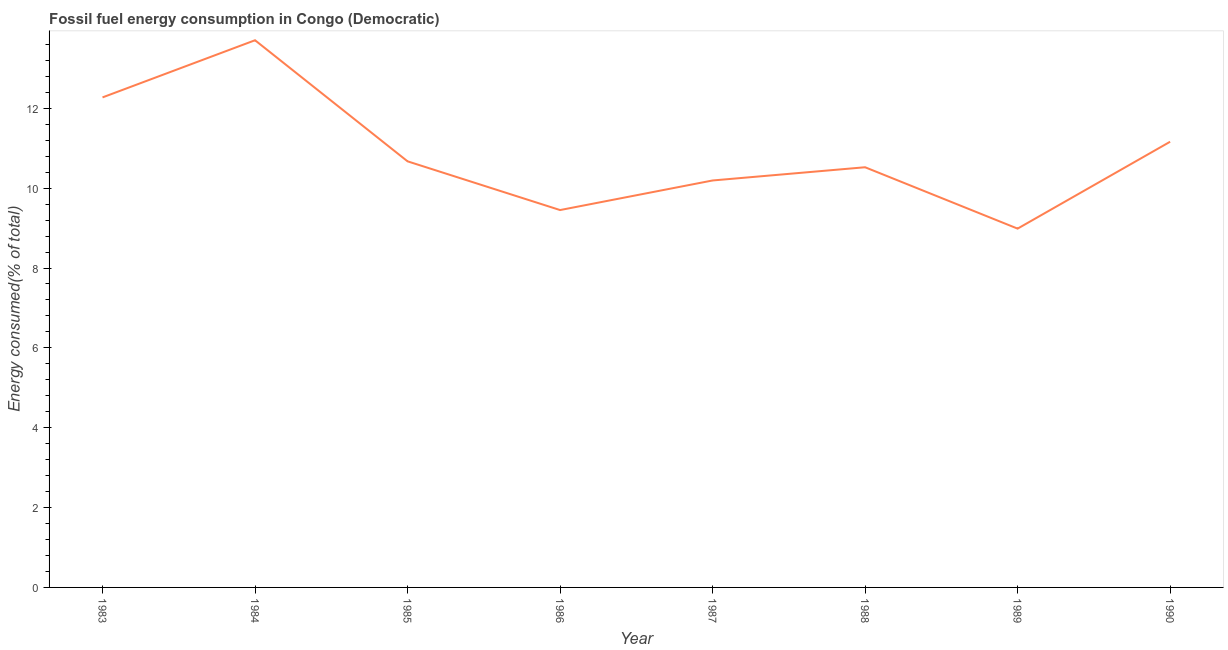What is the fossil fuel energy consumption in 1987?
Your answer should be compact. 10.19. Across all years, what is the maximum fossil fuel energy consumption?
Provide a succinct answer. 13.7. Across all years, what is the minimum fossil fuel energy consumption?
Your answer should be compact. 8.99. In which year was the fossil fuel energy consumption maximum?
Give a very brief answer. 1984. What is the sum of the fossil fuel energy consumption?
Make the answer very short. 86.97. What is the difference between the fossil fuel energy consumption in 1988 and 1989?
Your answer should be compact. 1.54. What is the average fossil fuel energy consumption per year?
Your answer should be very brief. 10.87. What is the median fossil fuel energy consumption?
Provide a short and direct response. 10.6. In how many years, is the fossil fuel energy consumption greater than 8 %?
Make the answer very short. 8. What is the ratio of the fossil fuel energy consumption in 1987 to that in 1990?
Your response must be concise. 0.91. What is the difference between the highest and the second highest fossil fuel energy consumption?
Your response must be concise. 1.43. Is the sum of the fossil fuel energy consumption in 1984 and 1988 greater than the maximum fossil fuel energy consumption across all years?
Your response must be concise. Yes. What is the difference between the highest and the lowest fossil fuel energy consumption?
Give a very brief answer. 4.72. How many years are there in the graph?
Provide a short and direct response. 8. Are the values on the major ticks of Y-axis written in scientific E-notation?
Make the answer very short. No. Does the graph contain any zero values?
Offer a very short reply. No. Does the graph contain grids?
Provide a succinct answer. No. What is the title of the graph?
Make the answer very short. Fossil fuel energy consumption in Congo (Democratic). What is the label or title of the Y-axis?
Ensure brevity in your answer.  Energy consumed(% of total). What is the Energy consumed(% of total) in 1983?
Offer a terse response. 12.27. What is the Energy consumed(% of total) of 1984?
Offer a very short reply. 13.7. What is the Energy consumed(% of total) of 1985?
Offer a very short reply. 10.67. What is the Energy consumed(% of total) in 1986?
Offer a very short reply. 9.45. What is the Energy consumed(% of total) of 1987?
Provide a short and direct response. 10.19. What is the Energy consumed(% of total) in 1988?
Offer a terse response. 10.52. What is the Energy consumed(% of total) of 1989?
Offer a terse response. 8.99. What is the Energy consumed(% of total) of 1990?
Offer a very short reply. 11.16. What is the difference between the Energy consumed(% of total) in 1983 and 1984?
Give a very brief answer. -1.43. What is the difference between the Energy consumed(% of total) in 1983 and 1985?
Your answer should be compact. 1.6. What is the difference between the Energy consumed(% of total) in 1983 and 1986?
Offer a very short reply. 2.82. What is the difference between the Energy consumed(% of total) in 1983 and 1987?
Keep it short and to the point. 2.08. What is the difference between the Energy consumed(% of total) in 1983 and 1988?
Ensure brevity in your answer.  1.75. What is the difference between the Energy consumed(% of total) in 1983 and 1989?
Make the answer very short. 3.29. What is the difference between the Energy consumed(% of total) in 1983 and 1990?
Your response must be concise. 1.11. What is the difference between the Energy consumed(% of total) in 1984 and 1985?
Ensure brevity in your answer.  3.03. What is the difference between the Energy consumed(% of total) in 1984 and 1986?
Make the answer very short. 4.25. What is the difference between the Energy consumed(% of total) in 1984 and 1987?
Make the answer very short. 3.51. What is the difference between the Energy consumed(% of total) in 1984 and 1988?
Provide a succinct answer. 3.18. What is the difference between the Energy consumed(% of total) in 1984 and 1989?
Your answer should be compact. 4.72. What is the difference between the Energy consumed(% of total) in 1984 and 1990?
Your answer should be very brief. 2.54. What is the difference between the Energy consumed(% of total) in 1985 and 1986?
Your answer should be compact. 1.22. What is the difference between the Energy consumed(% of total) in 1985 and 1987?
Offer a terse response. 0.48. What is the difference between the Energy consumed(% of total) in 1985 and 1988?
Provide a short and direct response. 0.15. What is the difference between the Energy consumed(% of total) in 1985 and 1989?
Provide a short and direct response. 1.69. What is the difference between the Energy consumed(% of total) in 1985 and 1990?
Offer a very short reply. -0.49. What is the difference between the Energy consumed(% of total) in 1986 and 1987?
Give a very brief answer. -0.74. What is the difference between the Energy consumed(% of total) in 1986 and 1988?
Make the answer very short. -1.07. What is the difference between the Energy consumed(% of total) in 1986 and 1989?
Your answer should be very brief. 0.47. What is the difference between the Energy consumed(% of total) in 1986 and 1990?
Keep it short and to the point. -1.71. What is the difference between the Energy consumed(% of total) in 1987 and 1988?
Offer a terse response. -0.33. What is the difference between the Energy consumed(% of total) in 1987 and 1989?
Your response must be concise. 1.21. What is the difference between the Energy consumed(% of total) in 1987 and 1990?
Provide a succinct answer. -0.97. What is the difference between the Energy consumed(% of total) in 1988 and 1989?
Provide a succinct answer. 1.54. What is the difference between the Energy consumed(% of total) in 1988 and 1990?
Offer a terse response. -0.64. What is the difference between the Energy consumed(% of total) in 1989 and 1990?
Offer a terse response. -2.18. What is the ratio of the Energy consumed(% of total) in 1983 to that in 1984?
Make the answer very short. 0.9. What is the ratio of the Energy consumed(% of total) in 1983 to that in 1985?
Offer a very short reply. 1.15. What is the ratio of the Energy consumed(% of total) in 1983 to that in 1986?
Your response must be concise. 1.3. What is the ratio of the Energy consumed(% of total) in 1983 to that in 1987?
Give a very brief answer. 1.2. What is the ratio of the Energy consumed(% of total) in 1983 to that in 1988?
Make the answer very short. 1.17. What is the ratio of the Energy consumed(% of total) in 1983 to that in 1989?
Your answer should be very brief. 1.37. What is the ratio of the Energy consumed(% of total) in 1984 to that in 1985?
Your answer should be compact. 1.28. What is the ratio of the Energy consumed(% of total) in 1984 to that in 1986?
Your answer should be very brief. 1.45. What is the ratio of the Energy consumed(% of total) in 1984 to that in 1987?
Make the answer very short. 1.34. What is the ratio of the Energy consumed(% of total) in 1984 to that in 1988?
Offer a very short reply. 1.3. What is the ratio of the Energy consumed(% of total) in 1984 to that in 1989?
Your answer should be compact. 1.52. What is the ratio of the Energy consumed(% of total) in 1984 to that in 1990?
Your answer should be compact. 1.23. What is the ratio of the Energy consumed(% of total) in 1985 to that in 1986?
Provide a succinct answer. 1.13. What is the ratio of the Energy consumed(% of total) in 1985 to that in 1987?
Provide a succinct answer. 1.05. What is the ratio of the Energy consumed(% of total) in 1985 to that in 1988?
Provide a succinct answer. 1.01. What is the ratio of the Energy consumed(% of total) in 1985 to that in 1989?
Give a very brief answer. 1.19. What is the ratio of the Energy consumed(% of total) in 1985 to that in 1990?
Offer a terse response. 0.96. What is the ratio of the Energy consumed(% of total) in 1986 to that in 1987?
Offer a very short reply. 0.93. What is the ratio of the Energy consumed(% of total) in 1986 to that in 1988?
Offer a very short reply. 0.9. What is the ratio of the Energy consumed(% of total) in 1986 to that in 1989?
Provide a succinct answer. 1.05. What is the ratio of the Energy consumed(% of total) in 1986 to that in 1990?
Provide a succinct answer. 0.85. What is the ratio of the Energy consumed(% of total) in 1987 to that in 1989?
Keep it short and to the point. 1.13. What is the ratio of the Energy consumed(% of total) in 1988 to that in 1989?
Provide a succinct answer. 1.17. What is the ratio of the Energy consumed(% of total) in 1988 to that in 1990?
Provide a succinct answer. 0.94. What is the ratio of the Energy consumed(% of total) in 1989 to that in 1990?
Ensure brevity in your answer.  0.81. 